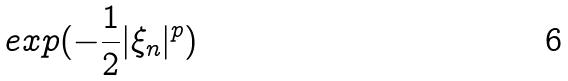<formula> <loc_0><loc_0><loc_500><loc_500>e x p ( - \frac { 1 } { 2 } | \xi _ { n } | ^ { p } )</formula> 